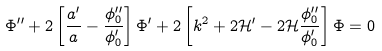Convert formula to latex. <formula><loc_0><loc_0><loc_500><loc_500>\Phi ^ { \prime \prime } + 2 \left [ \frac { a ^ { \prime } } { a } - \frac { \phi _ { 0 } ^ { \prime \prime } } { \phi _ { 0 } ^ { \prime } } \right ] \Phi ^ { \prime } + 2 \left [ k ^ { 2 } + 2 \mathcal { H } ^ { \prime } - 2 \mathcal { H } \frac { \phi _ { 0 } ^ { \prime \prime } } { \phi _ { 0 } ^ { \prime } } \right ] \Phi = 0</formula> 